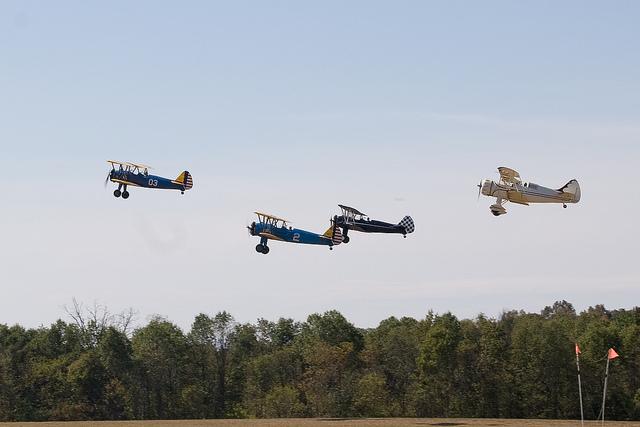Are these planes flying symmetrically?
Keep it brief. Yes. Where are the trees?
Keep it brief. Below planes. How many flags are visible?
Keep it brief. 2. 